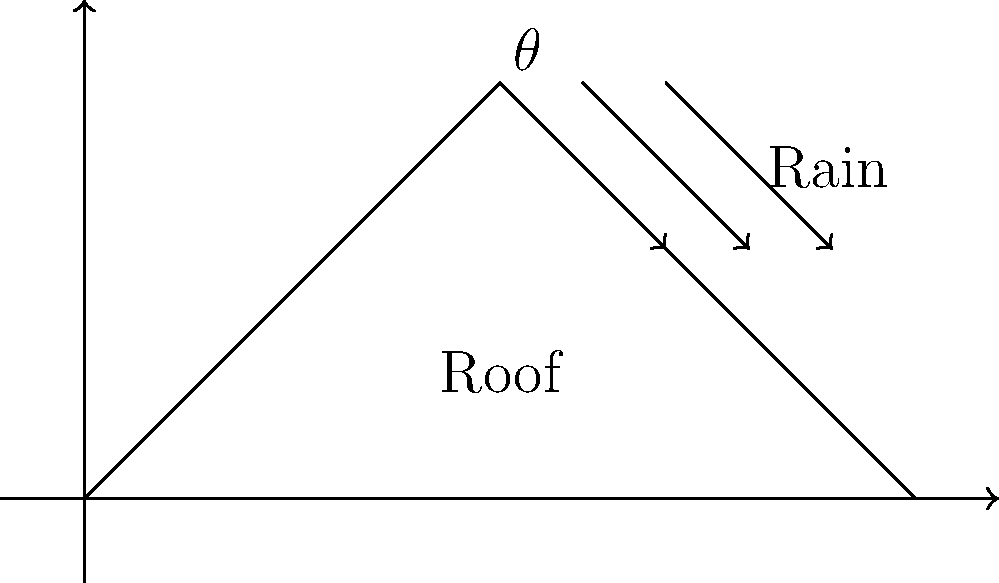As a singer-songwriter inspired by various eras, you're designing a music studio with optimal acoustics. The roof's angle affects both sound reflection and rainwater runoff. Given that the optimal angle for rainwater runoff is related to the tangent of the roof angle, which equation would you use to determine the angle $\theta$ that maximizes runoff, considering factors like rainfall intensity (I), roof length (L), and a runoff coefficient (C)? To determine the optimal angle for maximizing rainwater runoff, we need to consider the following factors:

1. Rainfall intensity (I): The amount of rain falling in a given time.
2. Roof length (L): The horizontal distance from eave to ridge.
3. Runoff coefficient (C): A factor that accounts for surface material and slope.

The optimal angle can be determined using the following steps:

1. The flow rate of water on the roof is given by the Rational Method:
   $Q = CIA$
   Where $Q$ is the flow rate, $C$ is the runoff coefficient, $I$ is the rainfall intensity, and $A$ is the roof area.

2. The roof area $A$ can be expressed as $L \cdot \sec(\theta)$, where $L$ is the horizontal roof length and $\theta$ is the roof angle.

3. Substituting this into the flow rate equation:
   $Q = CI \cdot L \cdot \sec(\theta)$

4. To maximize runoff, we want to maximize $Q$. Since $C$, $I$, and $L$ are constants, we need to maximize $\sec(\theta)$.

5. The maximum value of $\sec(\theta)$ occurs when $\tan(\theta)$ is at its maximum.

6. The optimal angle $\theta$ can be found by setting the derivative of $\tan(\theta)$ to zero:
   $\frac{d}{d\theta}(\tan(\theta)) = \sec^2(\theta) = 0$

7. This equation has no real solution, but in practice, the optimal angle is typically between 30° and 45°, depending on local conditions.

Therefore, the equation to determine the optimal angle $\theta$ that maximizes runoff is:

$\theta_{optimal} = \arctan(\max(\tan(\theta)))$

Where the maximum value of $\tan(\theta)$ is determined by local conditions and constraints.
Answer: $\theta_{optimal} = \arctan(\max(\tan(\theta)))$ 